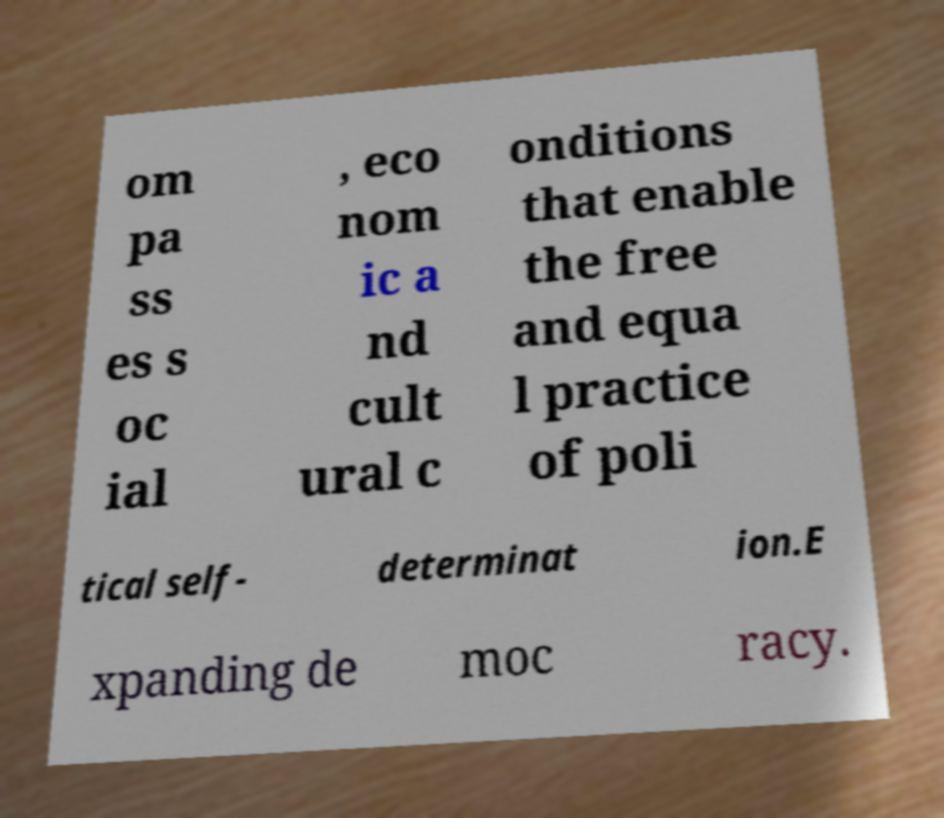For documentation purposes, I need the text within this image transcribed. Could you provide that? om pa ss es s oc ial , eco nom ic a nd cult ural c onditions that enable the free and equa l practice of poli tical self- determinat ion.E xpanding de moc racy. 